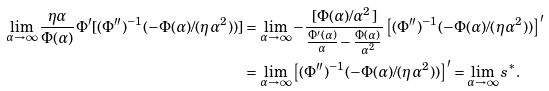Convert formula to latex. <formula><loc_0><loc_0><loc_500><loc_500>\lim _ { \alpha \to \infty } \frac { \eta \alpha } { \Phi ( \alpha ) } \Phi ^ { \prime } [ ( \Phi { ^ { \prime \prime } } ) ^ { - 1 } ( - \Phi ( \alpha ) / ( \eta \alpha ^ { 2 } ) ) ] & = \lim _ { \alpha \to \infty } - \frac { [ \Phi ( \alpha ) / \alpha ^ { 2 } ] } { \frac { \Phi ^ { \prime } ( \alpha ) } { \alpha } - \frac { \Phi ( \alpha ) } { \alpha ^ { 2 } } } \left [ ( \Phi { ^ { \prime \prime } } ) ^ { - 1 } ( - \Phi ( \alpha ) / ( \eta \alpha ^ { 2 } ) ) \right ] ^ { \prime } \\ & = \lim _ { \alpha \to \infty } \left [ ( \Phi { ^ { \prime \prime } } ) ^ { - 1 } ( - \Phi ( \alpha ) / ( \eta \alpha ^ { 2 } ) ) \right ] ^ { \prime } = \lim _ { \alpha \to \infty } s ^ { * } .</formula> 